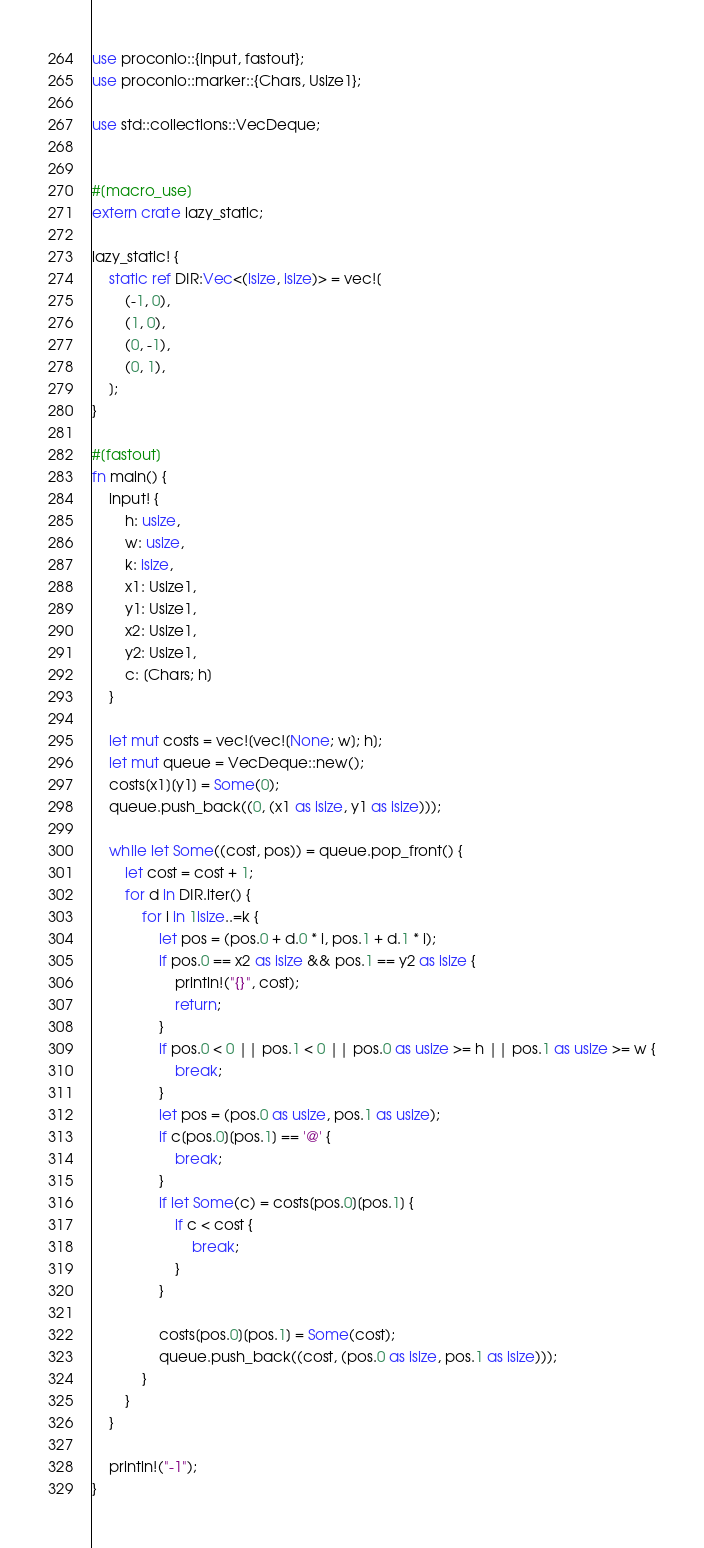<code> <loc_0><loc_0><loc_500><loc_500><_Rust_>use proconio::{input, fastout};
use proconio::marker::{Chars, Usize1};

use std::collections::VecDeque;


#[macro_use]
extern crate lazy_static;

lazy_static! {
    static ref DIR:Vec<(isize, isize)> = vec![
        (-1, 0),
        (1, 0),
        (0, -1),
        (0, 1),
    ];
}

#[fastout]
fn main() {
    input! {
        h: usize,
        w: usize,
        k: isize,
        x1: Usize1,
        y1: Usize1,
        x2: Usize1,
        y2: Usize1,
        c: [Chars; h]
    }

    let mut costs = vec![vec![None; w]; h];
    let mut queue = VecDeque::new();
    costs[x1][y1] = Some(0);
    queue.push_back((0, (x1 as isize, y1 as isize)));

    while let Some((cost, pos)) = queue.pop_front() {
        let cost = cost + 1;
        for d in DIR.iter() {
            for i in 1isize..=k {
                let pos = (pos.0 + d.0 * i, pos.1 + d.1 * i);
                if pos.0 == x2 as isize && pos.1 == y2 as isize {
                    println!("{}", cost);
                    return;
                }
                if pos.0 < 0 || pos.1 < 0 || pos.0 as usize >= h || pos.1 as usize >= w {
                    break;
                }
                let pos = (pos.0 as usize, pos.1 as usize);
                if c[pos.0][pos.1] == '@' {
                    break;
                }
                if let Some(c) = costs[pos.0][pos.1] {
                    if c < cost {
                        break;
                    }
                }

                costs[pos.0][pos.1] = Some(cost);
                queue.push_back((cost, (pos.0 as isize, pos.1 as isize)));
            }
        }
    }

    println!("-1");
}</code> 